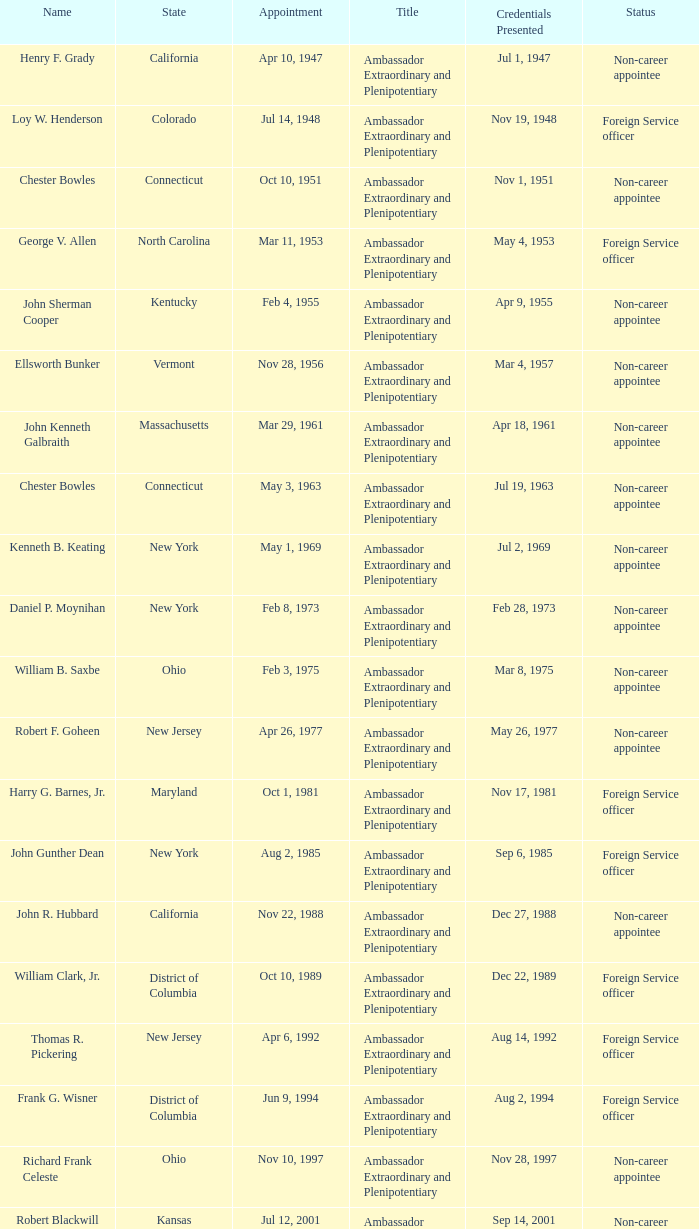What is the title for david campbell mulford? Ambassador Extraordinary and Plenipotentiary. 